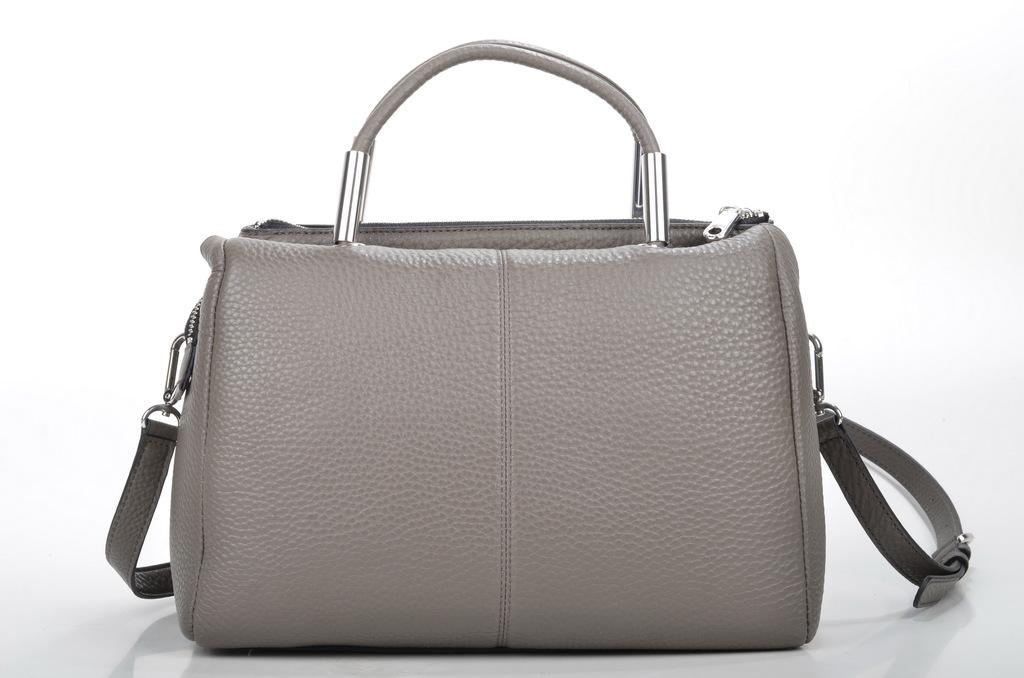What color is the handbag in the image? The handbag is grey in color. What type of authority figure is depicted holding the handbag in the image? There is no authority figure or handbag being held in the image; it only shows a grey handbag. 